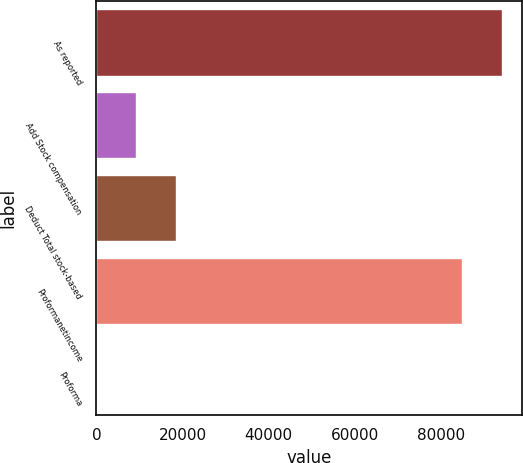Convert chart. <chart><loc_0><loc_0><loc_500><loc_500><bar_chart><fcel>As reported<fcel>Add Stock compensation<fcel>Deduct Total stock-based<fcel>Proformanetincome<fcel>Proforma<nl><fcel>94281.4<fcel>9291.58<fcel>18581<fcel>84992<fcel>2.2<nl></chart> 